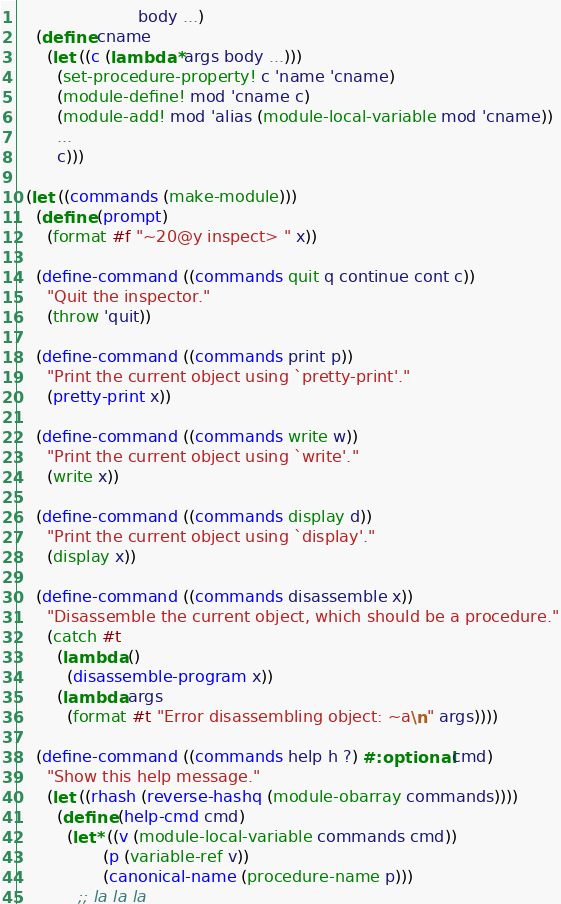Convert code to text. <code><loc_0><loc_0><loc_500><loc_500><_Scheme_>                        body ...)
    (define cname
      (let ((c (lambda* args body ...)))
        (set-procedure-property! c 'name 'cname)
        (module-define! mod 'cname c)
        (module-add! mod 'alias (module-local-variable mod 'cname))
        ...
        c)))

  (let ((commands (make-module)))
    (define (prompt)
      (format #f "~20@y inspect> " x))
      
    (define-command ((commands quit q continue cont c))
      "Quit the inspector."
      (throw 'quit))
      
    (define-command ((commands print p))
      "Print the current object using `pretty-print'."
      (pretty-print x))
      
    (define-command ((commands write w))
      "Print the current object using `write'."
      (write x))
      
    (define-command ((commands display d))
      "Print the current object using `display'."
      (display x))
      
    (define-command ((commands disassemble x))
      "Disassemble the current object, which should be a procedure."
      (catch #t
        (lambda ()
          (disassemble-program x))
        (lambda args
          (format #t "Error disassembling object: ~a\n" args))))
    
    (define-command ((commands help h ?) #:optional cmd)
      "Show this help message."
      (let ((rhash (reverse-hashq (module-obarray commands))))
        (define (help-cmd cmd)
          (let* ((v (module-local-variable commands cmd))
                 (p (variable-ref v))
                 (canonical-name (procedure-name p)))
            ;; la la la</code> 